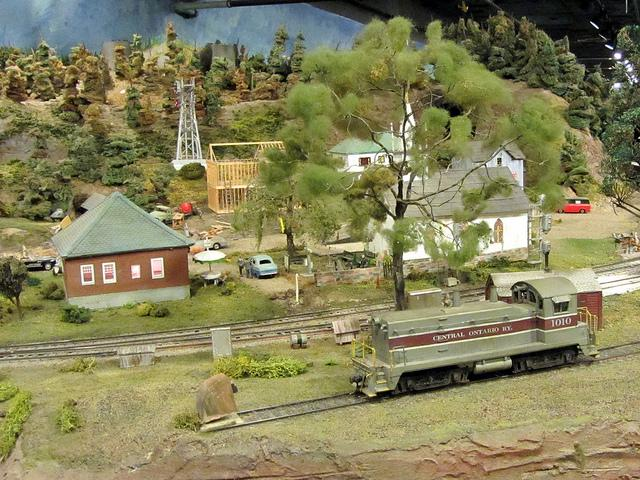What type of scene is this? Please explain your reasoning. model. There is a small train and houses present with figuirines. 